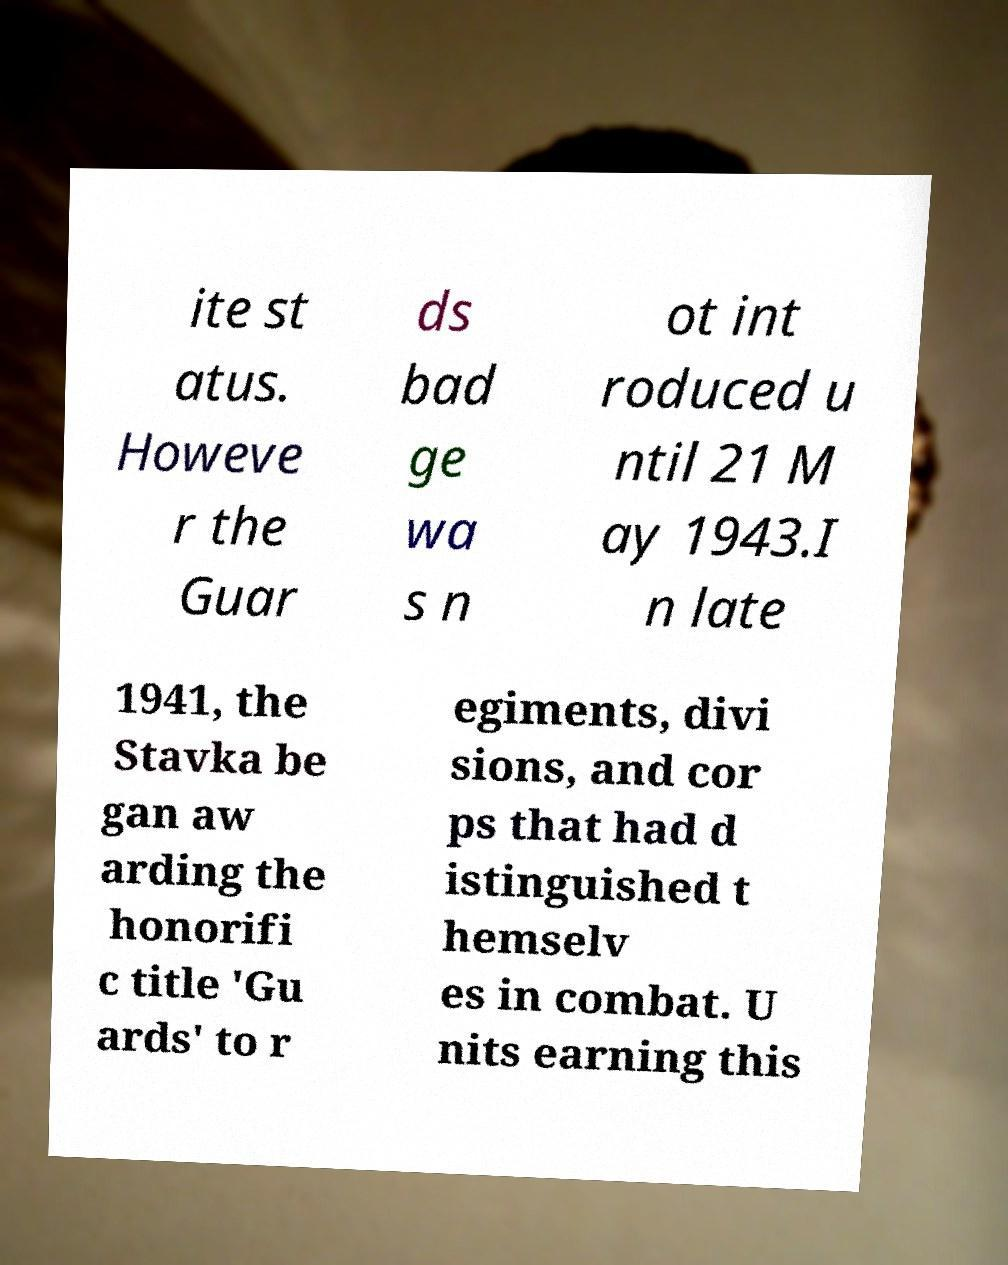Could you extract and type out the text from this image? ite st atus. Howeve r the Guar ds bad ge wa s n ot int roduced u ntil 21 M ay 1943.I n late 1941, the Stavka be gan aw arding the honorifi c title 'Gu ards' to r egiments, divi sions, and cor ps that had d istinguished t hemselv es in combat. U nits earning this 